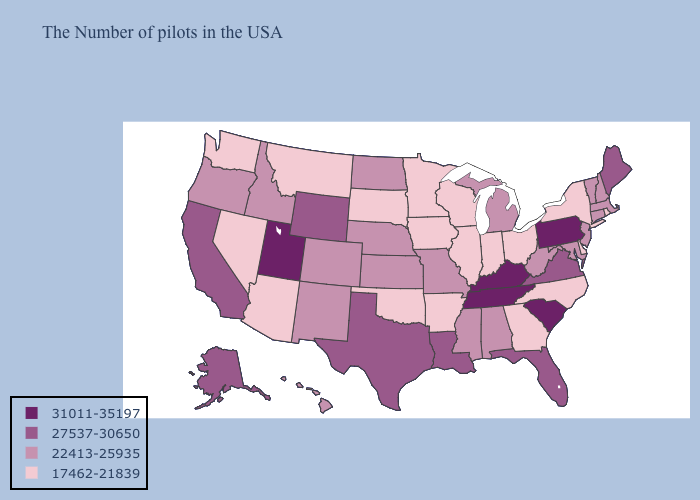What is the lowest value in states that border Minnesota?
Answer briefly. 17462-21839. Among the states that border New Jersey , does New York have the highest value?
Quick response, please. No. What is the value of Tennessee?
Keep it brief. 31011-35197. What is the lowest value in states that border Michigan?
Short answer required. 17462-21839. Name the states that have a value in the range 27537-30650?
Write a very short answer. Maine, Virginia, Florida, Louisiana, Texas, Wyoming, California, Alaska. Which states have the lowest value in the USA?
Quick response, please. Rhode Island, New York, Delaware, North Carolina, Ohio, Georgia, Indiana, Wisconsin, Illinois, Arkansas, Minnesota, Iowa, Oklahoma, South Dakota, Montana, Arizona, Nevada, Washington. Is the legend a continuous bar?
Be succinct. No. Name the states that have a value in the range 27537-30650?
Keep it brief. Maine, Virginia, Florida, Louisiana, Texas, Wyoming, California, Alaska. How many symbols are there in the legend?
Be succinct. 4. What is the value of New York?
Quick response, please. 17462-21839. Does Connecticut have a higher value than North Carolina?
Quick response, please. Yes. Does Kentucky have the highest value in the USA?
Quick response, please. Yes. Is the legend a continuous bar?
Write a very short answer. No. What is the highest value in the MidWest ?
Concise answer only. 22413-25935. Does Tennessee have the highest value in the USA?
Quick response, please. Yes. 